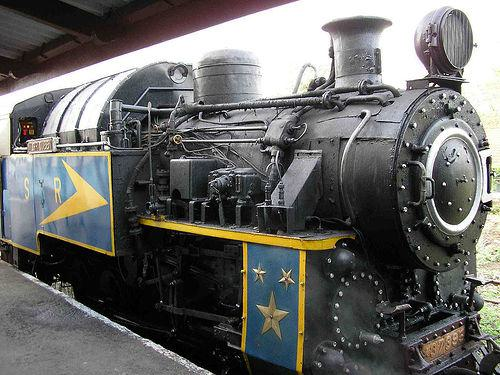Would there be a train in the image once the train has been removed from the scence? No 